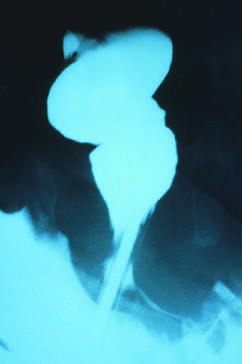what were absent in the rectum, presented in the sigmoid colon?
Answer the question using a single word or phrase. Ganglion cells 